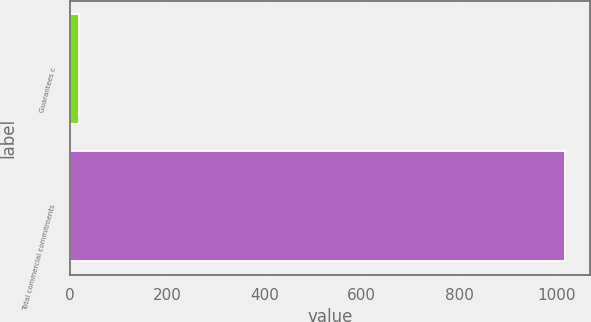<chart> <loc_0><loc_0><loc_500><loc_500><bar_chart><fcel>Guarantees c<fcel>Total commercial commitments<nl><fcel>18<fcel>1018<nl></chart> 